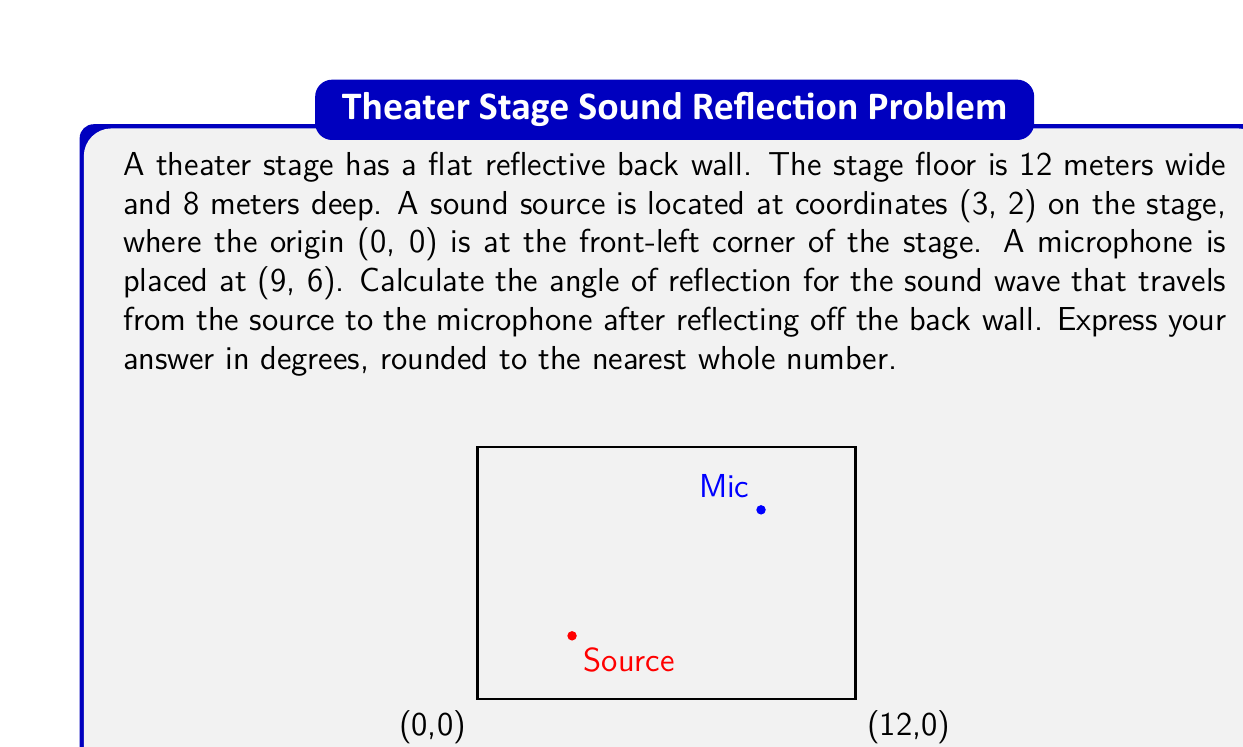Can you solve this math problem? To solve this problem, we'll use vector mathematics and the law of reflection. Let's break it down step-by-step:

1) First, we need to find the coordinates of the reflection point on the back wall. Let's call this point R(x, 8), as we know its y-coordinate will be 8 (the depth of the stage).

2) The incident vector $\vec{i}$ from the source S(3, 2) to R(x, 8) is:
   $$\vec{i} = (x-3, 6)$$

3) The reflected vector $\vec{r}$ from R(x, 8) to the microphone M(9, 6) is:
   $$\vec{r} = (9-x, -2)$$

4) The normal vector $\vec{n}$ to the back wall is:
   $$\vec{n} = (0, -1)$$

5) According to the law of reflection, the angle of incidence equals the angle of reflection. This means that the dot products of $\vec{i}$ and $\vec{n}$, and $\vec{r}$ and $\vec{n}$ should be equal:

   $$\frac{\vec{i} \cdot \vec{n}}{|\vec{i}||\vec{n}|} = \frac{\vec{r} \cdot \vec{n}}{|\vec{r}||\vec{n}|}$$

6) Expanding this equation:
   $$\frac{6}{\sqrt{(x-3)^2 + 36}} = \frac{2}{\sqrt{(9-x)^2 + 4}}$$

7) Solving this equation (which involves squaring both sides and simplifying), we get:
   $$x = 6$$

8) So, the reflection point R is at (6, 8).

9) Now, we can calculate the angle of reflection. We'll use the dot product between $\vec{r}$ and $\vec{n}$:

   $$\cos \theta = \frac{\vec{r} \cdot \vec{n}}{|\vec{r}||\vec{n}|} = \frac{2}{\sqrt{3^2 + 2^2}} = \frac{2}{\sqrt{13}}$$

10) Taking the inverse cosine and converting to degrees:
    $$\theta = \arccos(\frac{2}{\sqrt{13}}) \approx 56.31°$$

11) Rounding to the nearest whole number:
    $$\theta \approx 56°$$
Answer: 56° 